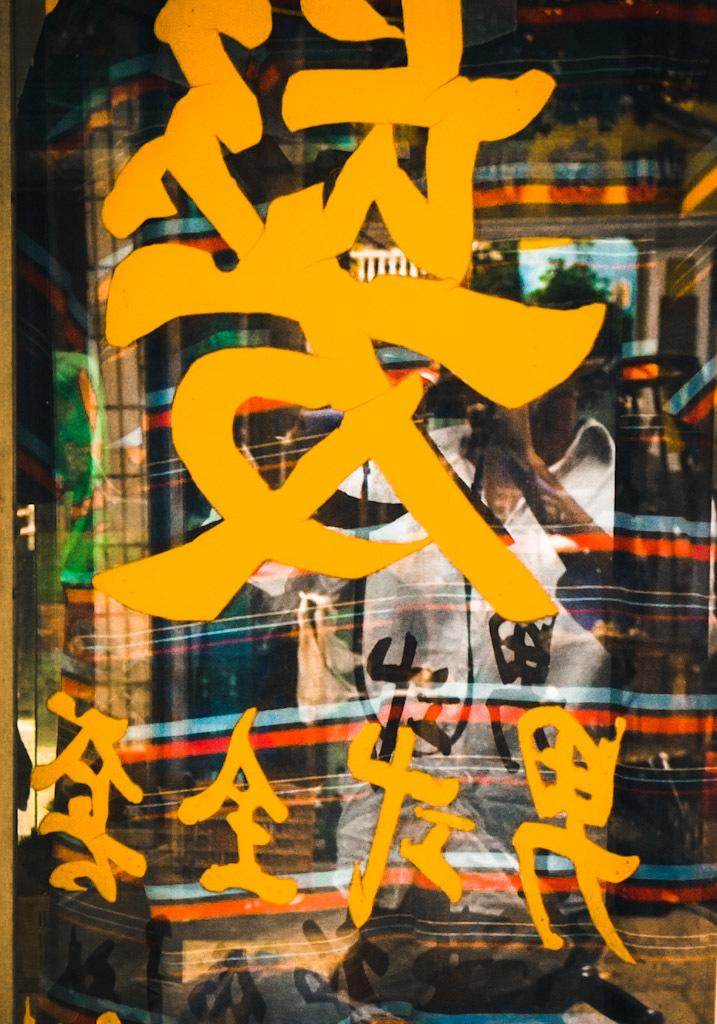What type of surface is visible in the image? There is a glass surface in the image. What can be seen written on the glass surface? Something is written on the glass surface with yellow color. What is reflected on the glass surface? There is a reflection of a person on the glass surface. What color is the dress worn by the person in the reflection? The person is wearing a white-colored dress. What type of hands can be seen holding a rifle in the image? There are no hands or rifles present in the image. 